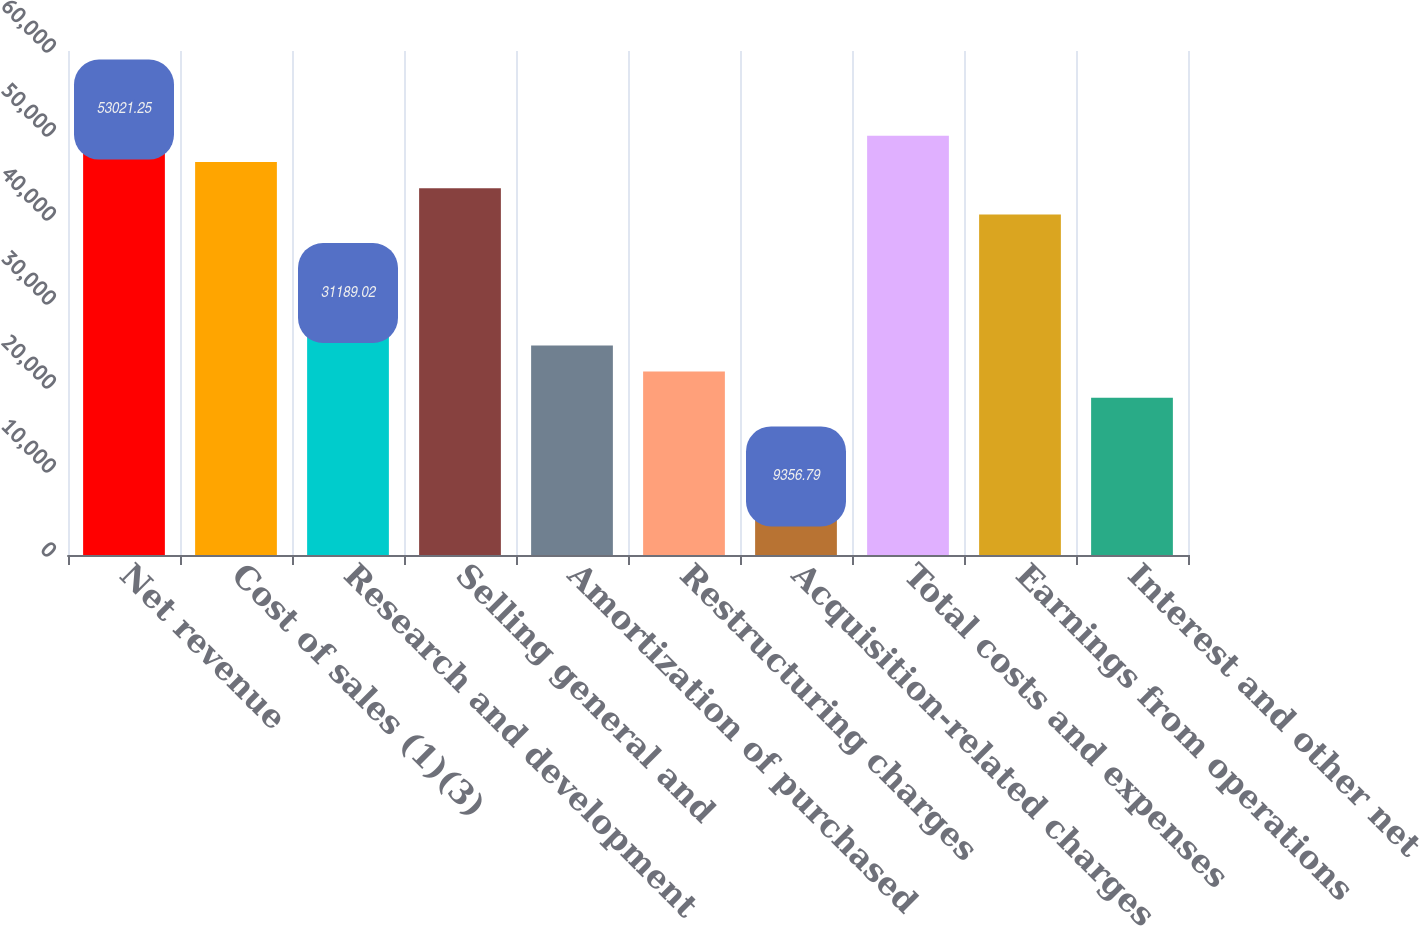<chart> <loc_0><loc_0><loc_500><loc_500><bar_chart><fcel>Net revenue<fcel>Cost of sales (1)(3)<fcel>Research and development<fcel>Selling general and<fcel>Amortization of purchased<fcel>Restructuring charges<fcel>Acquisition-related charges<fcel>Total costs and expenses<fcel>Earnings from operations<fcel>Interest and other net<nl><fcel>53021.2<fcel>46783.5<fcel>31189<fcel>43664.6<fcel>24951.2<fcel>21832.3<fcel>9356.79<fcel>49902.4<fcel>40545.7<fcel>18713.5<nl></chart> 